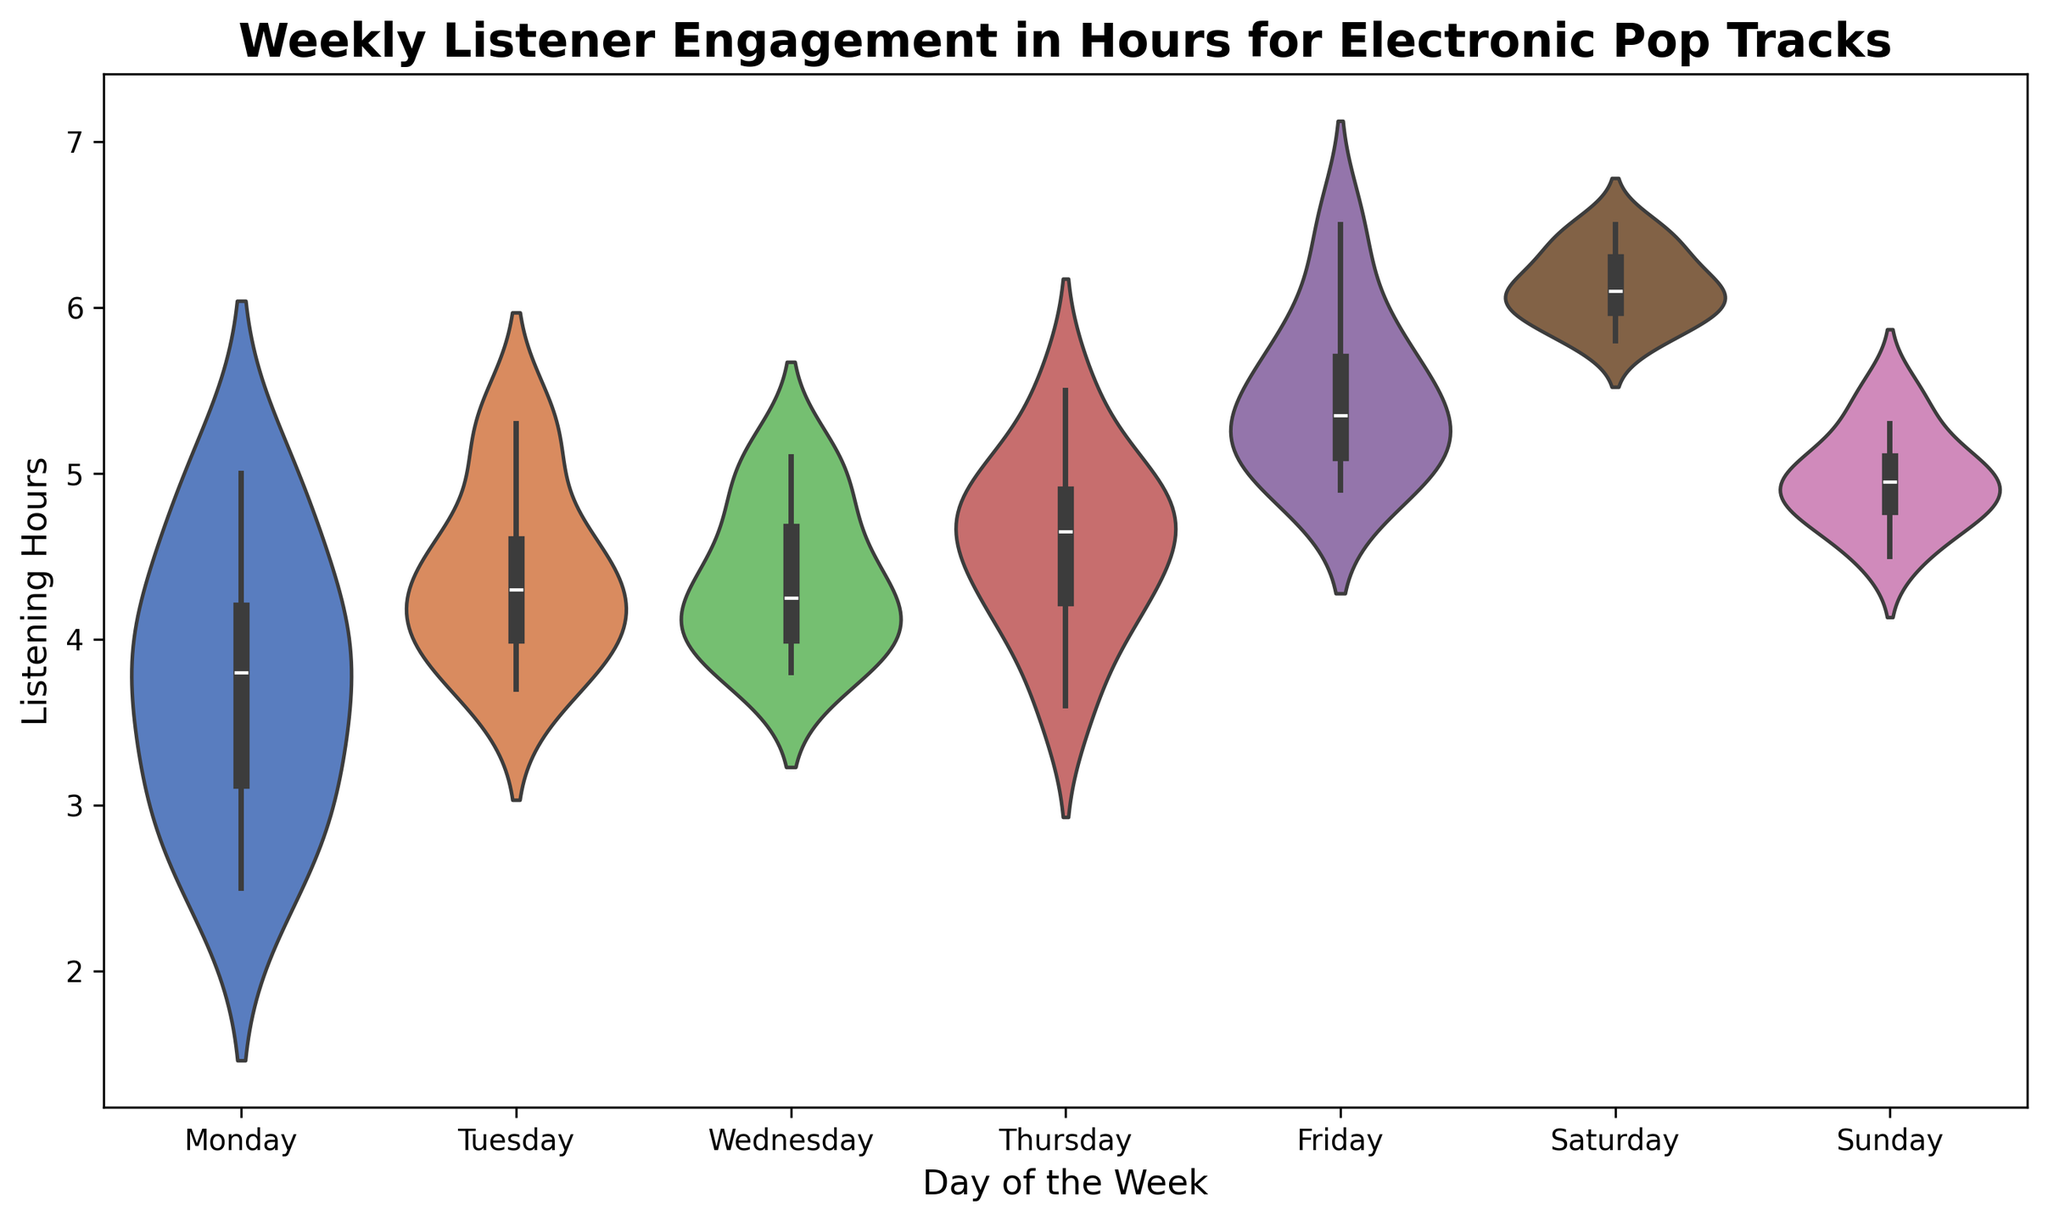Which day has the highest median listener engagement in hours? To determine the day with the highest median listener engagement, look at the median line within each violin plot. The violin plot for Saturday has the highest median line compared to other days.
Answer: Saturday Which day shows the widest interquartile range (IQR) in listener engagement? The IQR can be observed by looking at the spread of the middle 50% within the box inside each violin plot. Friday's box appears wider, indicating a larger IQR compared to other days.
Answer: Friday How does the variability of listener engagement on Monday compare to Wednesday? Variability can be assessed by the width and spread of the violin plots. Monday's plot is more spread out at the tails, suggesting higher variability, whereas Wednesday's plot is more concentrated with a narrower spread.
Answer: Monday has higher variability On which day is the listener engagement most consistently centered around the median? This can be determined by identifying the day with the narrowest violin shape at the median area. Tuesday's plot shows a concentrated area at the median, indicating consistent engagement around that value.
Answer: Tuesday Which day has the smallest range of listener engagement? The range can be observed by the overall height of the violin plot from the minimum to maximum values. Monday has the shortest height, indicating the smallest range of engagement.
Answer: Monday Are there any days where the maximum listener engagement hours exceed 6 hours? If so, which days? By looking at the top extent of each violin plot, we see that Friday and Saturday both have maximum engagement hours exceeding 6 hours.
Answer: Friday and Saturday 